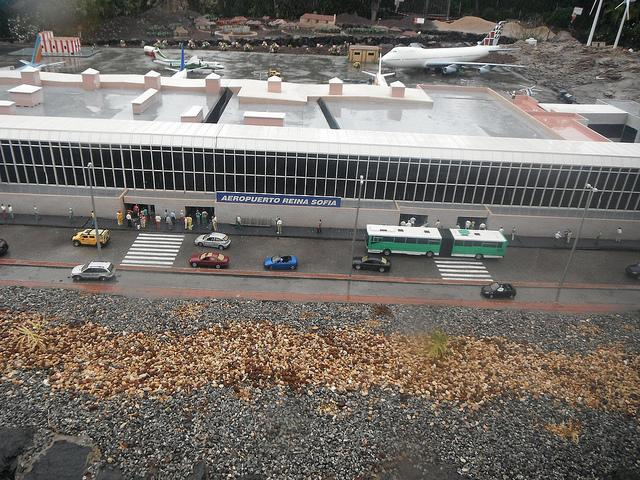What country is this location? spain 